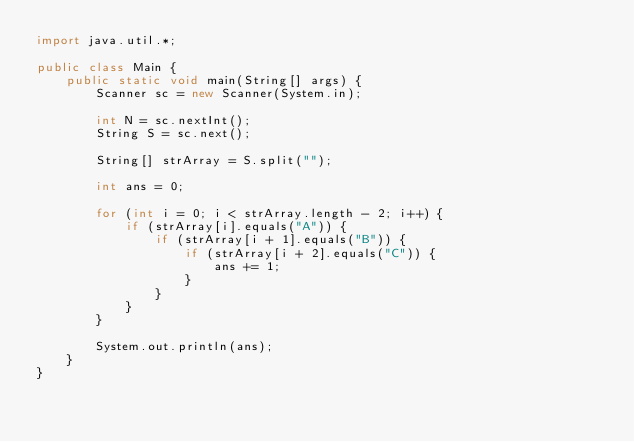Convert code to text. <code><loc_0><loc_0><loc_500><loc_500><_Java_>import java.util.*;

public class Main {
    public static void main(String[] args) {
        Scanner sc = new Scanner(System.in);

        int N = sc.nextInt();
        String S = sc.next();

        String[] strArray = S.split("");

        int ans = 0;

        for (int i = 0; i < strArray.length - 2; i++) {
            if (strArray[i].equals("A")) {
                if (strArray[i + 1].equals("B")) {
                    if (strArray[i + 2].equals("C")) {
                        ans += 1;
                    }
                }
            }
        }

        System.out.println(ans);
    }
}</code> 